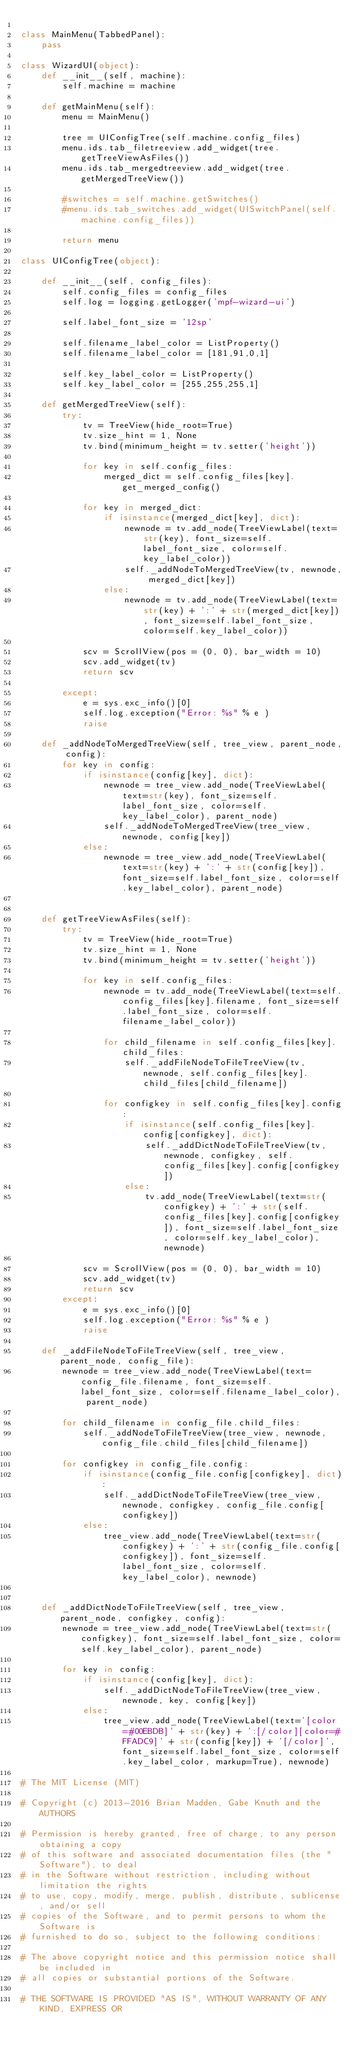<code> <loc_0><loc_0><loc_500><loc_500><_Python_>
class MainMenu(TabbedPanel):
    pass

class WizardUI(object):
    def __init__(self, machine):
        self.machine = machine
        
    def getMainMenu(self):
        menu = MainMenu()

        tree = UIConfigTree(self.machine.config_files)
        menu.ids.tab_filetreeview.add_widget(tree.getTreeViewAsFiles())
        menu.ids.tab_mergedtreeview.add_widget(tree.getMergedTreeView())

        #switches = self.machine.getSwitches()
        #menu.ids.tab_switches.add_widget(UISwitchPanel(self.machine.config_files))
        
        return menu
        
class UIConfigTree(object):
    
    def __init__(self, config_files):
        self.config_files = config_files
        self.log = logging.getLogger('mpf-wizard-ui')
        
        self.label_font_size = '12sp'
        
        self.filename_label_color = ListProperty()
        self.filename_label_color = [181,91,0,1]
        
        self.key_label_color = ListProperty()
        self.key_label_color = [255,255,255,1]
                
    def getMergedTreeView(self):
        try:
            tv = TreeView(hide_root=True)
            tv.size_hint = 1, None
            tv.bind(minimum_height = tv.setter('height'))
            
            for key in self.config_files:
                merged_dict = self.config_files[key].get_merged_config()
            
            for key in merged_dict:
                if isinstance(merged_dict[key], dict):
                    newnode = tv.add_node(TreeViewLabel(text=str(key), font_size=self.label_font_size, color=self.key_label_color))
                    self._addNodeToMergedTreeView(tv, newnode, merged_dict[key])
                else:
                    newnode = tv.add_node(TreeViewLabel(text=str(key) + ':' + str(merged_dict[key]), font_size=self.label_font_size, color=self.key_label_color))
            
            scv = ScrollView(pos = (0, 0), bar_width = 10)
            scv.add_widget(tv)
            return scv

        except:
            e = sys.exc_info()[0]
            self.log.exception("Error: %s" % e )
            raise
        
    def _addNodeToMergedTreeView(self, tree_view, parent_node, config):
        for key in config:
            if isinstance(config[key], dict):
                newnode = tree_view.add_node(TreeViewLabel(text=str(key), font_size=self.label_font_size, color=self.key_label_color), parent_node)
                self._addNodeToMergedTreeView(tree_view, newnode, config[key])
            else:
                newnode = tree_view.add_node(TreeViewLabel(text=str(key) + ':' + str(config[key]), font_size=self.label_font_size, color=self.key_label_color), parent_node)
        
        
    def getTreeViewAsFiles(self):
        try:
            tv = TreeView(hide_root=True)
            tv.size_hint = 1, None
            tv.bind(minimum_height = tv.setter('height'))
            
            for key in self.config_files:
                newnode = tv.add_node(TreeViewLabel(text=self.config_files[key].filename, font_size=self.label_font_size, color=self.filename_label_color))
                
                for child_filename in self.config_files[key].child_files:
                    self._addFileNodeToFileTreeView(tv, newnode, self.config_files[key].child_files[child_filename])
                    
                for configkey in self.config_files[key].config:
                    if isinstance(self.config_files[key].config[configkey], dict):
                        self._addDictNodeToFileTreeView(tv, newnode, configkey, self.config_files[key].config[configkey])
                    else:
                        tv.add_node(TreeViewLabel(text=str(configkey) + ':' + str(self.config_files[key].config[configkey]), font_size=self.label_font_size, color=self.key_label_color), newnode)
                                
            scv = ScrollView(pos = (0, 0), bar_width = 10)
            scv.add_widget(tv)
            return scv
        except:
            e = sys.exc_info()[0]
            self.log.exception("Error: %s" % e )
            raise
            
    def _addFileNodeToFileTreeView(self, tree_view, parent_node, config_file):
        newnode = tree_view.add_node(TreeViewLabel(text=config_file.filename, font_size=self.label_font_size, color=self.filename_label_color), parent_node)

        for child_filename in config_file.child_files:
            self._addNodeToFileTreeView(tree_view, newnode, config_file.child_files[child_filename])
    
        for configkey in config_file.config:
            if isinstance(config_file.config[configkey], dict):
                self._addDictNodeToFileTreeView(tree_view, newnode, configkey, config_file.config[configkey])
            else:
                tree_view.add_node(TreeViewLabel(text=str(configkey) + ':' + str(config_file.config[configkey]), font_size=self.label_font_size, color=self.key_label_color), newnode)


    def _addDictNodeToFileTreeView(self, tree_view, parent_node, configkey, config):
        newnode = tree_view.add_node(TreeViewLabel(text=str(configkey), font_size=self.label_font_size, color=self.key_label_color), parent_node)
        
        for key in config:
            if isinstance(config[key], dict):
                self._addDictNodeToFileTreeView(tree_view, newnode, key, config[key])
            else:
                tree_view.add_node(TreeViewLabel(text='[color=#00EBDB]' + str(key) + ':[/color][color=#FFADC9]' + str(config[key]) + '[/color]', font_size=self.label_font_size, color=self.key_label_color, markup=True), newnode)
        
# The MIT License (MIT)

# Copyright (c) 2013-2016 Brian Madden, Gabe Knuth and the AUTHORS

# Permission is hereby granted, free of charge, to any person obtaining a copy
# of this software and associated documentation files (the "Software"), to deal
# in the Software without restriction, including without limitation the rights
# to use, copy, modify, merge, publish, distribute, sublicense, and/or sell
# copies of the Software, and to permit persons to whom the Software is
# furnished to do so, subject to the following conditions:

# The above copyright notice and this permission notice shall be included in
# all copies or substantial portions of the Software.

# THE SOFTWARE IS PROVIDED "AS IS", WITHOUT WARRANTY OF ANY KIND, EXPRESS OR</code> 